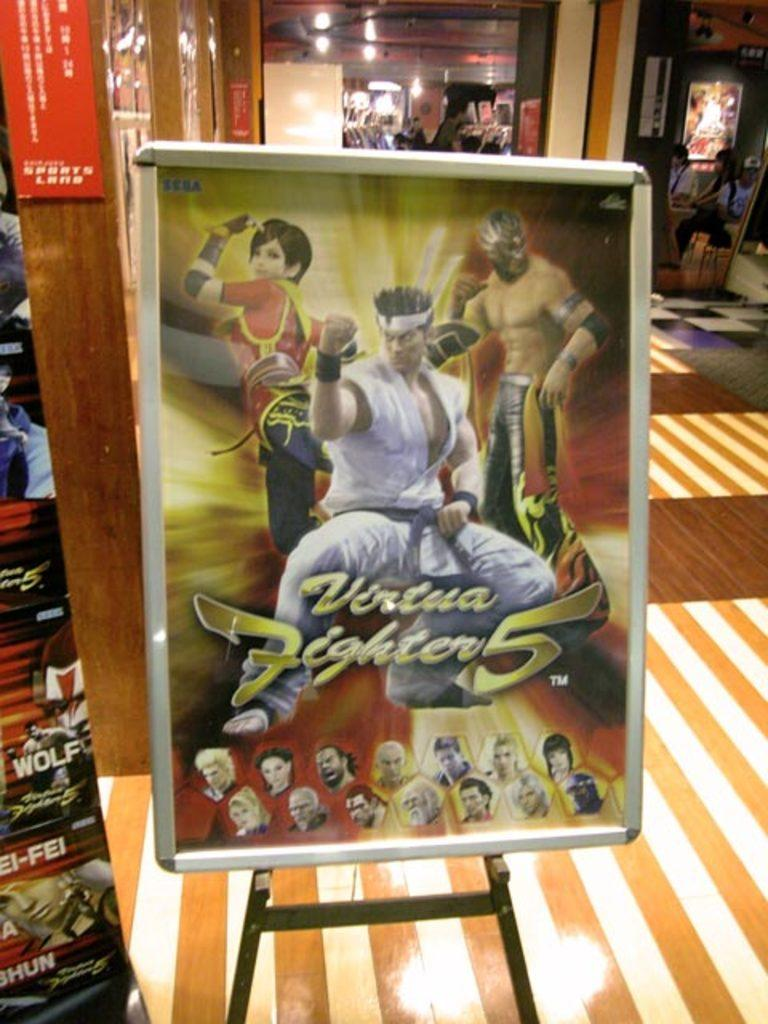<image>
Write a terse but informative summary of the picture. the name fighter is on the large poster 